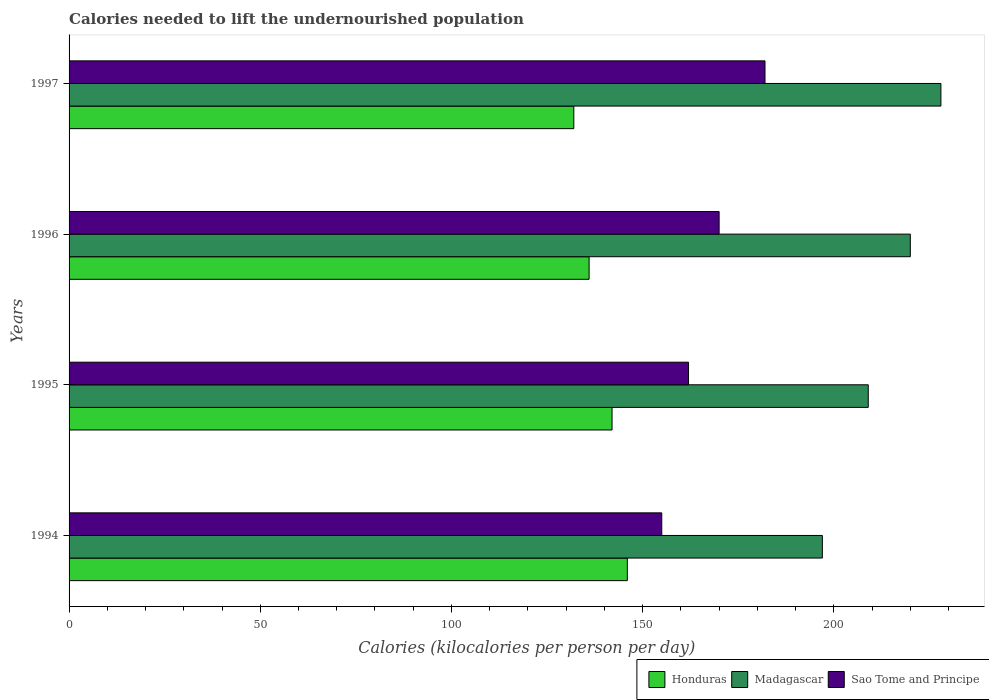How many different coloured bars are there?
Keep it short and to the point. 3. How many groups of bars are there?
Provide a short and direct response. 4. Are the number of bars on each tick of the Y-axis equal?
Your response must be concise. Yes. How many bars are there on the 4th tick from the top?
Keep it short and to the point. 3. What is the label of the 4th group of bars from the top?
Provide a succinct answer. 1994. In how many cases, is the number of bars for a given year not equal to the number of legend labels?
Ensure brevity in your answer.  0. What is the total calories needed to lift the undernourished population in Honduras in 1997?
Ensure brevity in your answer.  132. Across all years, what is the maximum total calories needed to lift the undernourished population in Sao Tome and Principe?
Make the answer very short. 182. Across all years, what is the minimum total calories needed to lift the undernourished population in Madagascar?
Provide a succinct answer. 197. In which year was the total calories needed to lift the undernourished population in Sao Tome and Principe maximum?
Make the answer very short. 1997. In which year was the total calories needed to lift the undernourished population in Sao Tome and Principe minimum?
Your answer should be very brief. 1994. What is the total total calories needed to lift the undernourished population in Madagascar in the graph?
Give a very brief answer. 854. What is the difference between the total calories needed to lift the undernourished population in Honduras in 1994 and that in 1996?
Your answer should be compact. 10. What is the difference between the total calories needed to lift the undernourished population in Honduras in 1996 and the total calories needed to lift the undernourished population in Madagascar in 1997?
Offer a terse response. -92. What is the average total calories needed to lift the undernourished population in Sao Tome and Principe per year?
Give a very brief answer. 167.25. In the year 1996, what is the difference between the total calories needed to lift the undernourished population in Honduras and total calories needed to lift the undernourished population in Sao Tome and Principe?
Your answer should be compact. -34. In how many years, is the total calories needed to lift the undernourished population in Sao Tome and Principe greater than 170 kilocalories?
Your answer should be compact. 1. What is the ratio of the total calories needed to lift the undernourished population in Sao Tome and Principe in 1994 to that in 1995?
Your response must be concise. 0.96. What is the difference between the highest and the lowest total calories needed to lift the undernourished population in Honduras?
Provide a short and direct response. 14. In how many years, is the total calories needed to lift the undernourished population in Madagascar greater than the average total calories needed to lift the undernourished population in Madagascar taken over all years?
Offer a very short reply. 2. What does the 1st bar from the top in 1994 represents?
Offer a very short reply. Sao Tome and Principe. What does the 2nd bar from the bottom in 1997 represents?
Offer a terse response. Madagascar. How many years are there in the graph?
Make the answer very short. 4. What is the difference between two consecutive major ticks on the X-axis?
Provide a short and direct response. 50. Does the graph contain grids?
Ensure brevity in your answer.  No. Where does the legend appear in the graph?
Keep it short and to the point. Bottom right. How many legend labels are there?
Provide a short and direct response. 3. How are the legend labels stacked?
Your answer should be compact. Horizontal. What is the title of the graph?
Keep it short and to the point. Calories needed to lift the undernourished population. What is the label or title of the X-axis?
Make the answer very short. Calories (kilocalories per person per day). What is the label or title of the Y-axis?
Offer a very short reply. Years. What is the Calories (kilocalories per person per day) of Honduras in 1994?
Make the answer very short. 146. What is the Calories (kilocalories per person per day) in Madagascar in 1994?
Provide a short and direct response. 197. What is the Calories (kilocalories per person per day) of Sao Tome and Principe in 1994?
Your answer should be compact. 155. What is the Calories (kilocalories per person per day) of Honduras in 1995?
Your response must be concise. 142. What is the Calories (kilocalories per person per day) in Madagascar in 1995?
Keep it short and to the point. 209. What is the Calories (kilocalories per person per day) in Sao Tome and Principe in 1995?
Give a very brief answer. 162. What is the Calories (kilocalories per person per day) of Honduras in 1996?
Give a very brief answer. 136. What is the Calories (kilocalories per person per day) of Madagascar in 1996?
Provide a short and direct response. 220. What is the Calories (kilocalories per person per day) in Sao Tome and Principe in 1996?
Your response must be concise. 170. What is the Calories (kilocalories per person per day) of Honduras in 1997?
Offer a terse response. 132. What is the Calories (kilocalories per person per day) of Madagascar in 1997?
Give a very brief answer. 228. What is the Calories (kilocalories per person per day) of Sao Tome and Principe in 1997?
Offer a terse response. 182. Across all years, what is the maximum Calories (kilocalories per person per day) of Honduras?
Offer a very short reply. 146. Across all years, what is the maximum Calories (kilocalories per person per day) of Madagascar?
Provide a short and direct response. 228. Across all years, what is the maximum Calories (kilocalories per person per day) of Sao Tome and Principe?
Keep it short and to the point. 182. Across all years, what is the minimum Calories (kilocalories per person per day) of Honduras?
Make the answer very short. 132. Across all years, what is the minimum Calories (kilocalories per person per day) in Madagascar?
Your answer should be compact. 197. Across all years, what is the minimum Calories (kilocalories per person per day) in Sao Tome and Principe?
Provide a short and direct response. 155. What is the total Calories (kilocalories per person per day) of Honduras in the graph?
Provide a succinct answer. 556. What is the total Calories (kilocalories per person per day) in Madagascar in the graph?
Keep it short and to the point. 854. What is the total Calories (kilocalories per person per day) in Sao Tome and Principe in the graph?
Provide a short and direct response. 669. What is the difference between the Calories (kilocalories per person per day) of Honduras in 1994 and that in 1995?
Your answer should be very brief. 4. What is the difference between the Calories (kilocalories per person per day) in Madagascar in 1994 and that in 1995?
Ensure brevity in your answer.  -12. What is the difference between the Calories (kilocalories per person per day) of Sao Tome and Principe in 1994 and that in 1995?
Your answer should be compact. -7. What is the difference between the Calories (kilocalories per person per day) in Madagascar in 1994 and that in 1996?
Make the answer very short. -23. What is the difference between the Calories (kilocalories per person per day) of Sao Tome and Principe in 1994 and that in 1996?
Keep it short and to the point. -15. What is the difference between the Calories (kilocalories per person per day) in Madagascar in 1994 and that in 1997?
Your response must be concise. -31. What is the difference between the Calories (kilocalories per person per day) of Sao Tome and Principe in 1994 and that in 1997?
Provide a succinct answer. -27. What is the difference between the Calories (kilocalories per person per day) in Madagascar in 1995 and that in 1996?
Keep it short and to the point. -11. What is the difference between the Calories (kilocalories per person per day) of Sao Tome and Principe in 1995 and that in 1997?
Your answer should be compact. -20. What is the difference between the Calories (kilocalories per person per day) of Madagascar in 1996 and that in 1997?
Your answer should be compact. -8. What is the difference between the Calories (kilocalories per person per day) in Honduras in 1994 and the Calories (kilocalories per person per day) in Madagascar in 1995?
Provide a succinct answer. -63. What is the difference between the Calories (kilocalories per person per day) of Honduras in 1994 and the Calories (kilocalories per person per day) of Sao Tome and Principe in 1995?
Provide a succinct answer. -16. What is the difference between the Calories (kilocalories per person per day) of Honduras in 1994 and the Calories (kilocalories per person per day) of Madagascar in 1996?
Give a very brief answer. -74. What is the difference between the Calories (kilocalories per person per day) in Honduras in 1994 and the Calories (kilocalories per person per day) in Sao Tome and Principe in 1996?
Provide a succinct answer. -24. What is the difference between the Calories (kilocalories per person per day) in Honduras in 1994 and the Calories (kilocalories per person per day) in Madagascar in 1997?
Your answer should be compact. -82. What is the difference between the Calories (kilocalories per person per day) of Honduras in 1994 and the Calories (kilocalories per person per day) of Sao Tome and Principe in 1997?
Offer a terse response. -36. What is the difference between the Calories (kilocalories per person per day) in Madagascar in 1994 and the Calories (kilocalories per person per day) in Sao Tome and Principe in 1997?
Your answer should be very brief. 15. What is the difference between the Calories (kilocalories per person per day) of Honduras in 1995 and the Calories (kilocalories per person per day) of Madagascar in 1996?
Your answer should be compact. -78. What is the difference between the Calories (kilocalories per person per day) of Honduras in 1995 and the Calories (kilocalories per person per day) of Sao Tome and Principe in 1996?
Your answer should be very brief. -28. What is the difference between the Calories (kilocalories per person per day) of Madagascar in 1995 and the Calories (kilocalories per person per day) of Sao Tome and Principe in 1996?
Your answer should be very brief. 39. What is the difference between the Calories (kilocalories per person per day) in Honduras in 1995 and the Calories (kilocalories per person per day) in Madagascar in 1997?
Your answer should be compact. -86. What is the difference between the Calories (kilocalories per person per day) in Honduras in 1995 and the Calories (kilocalories per person per day) in Sao Tome and Principe in 1997?
Offer a terse response. -40. What is the difference between the Calories (kilocalories per person per day) in Honduras in 1996 and the Calories (kilocalories per person per day) in Madagascar in 1997?
Keep it short and to the point. -92. What is the difference between the Calories (kilocalories per person per day) of Honduras in 1996 and the Calories (kilocalories per person per day) of Sao Tome and Principe in 1997?
Keep it short and to the point. -46. What is the average Calories (kilocalories per person per day) of Honduras per year?
Provide a succinct answer. 139. What is the average Calories (kilocalories per person per day) in Madagascar per year?
Your response must be concise. 213.5. What is the average Calories (kilocalories per person per day) in Sao Tome and Principe per year?
Your answer should be compact. 167.25. In the year 1994, what is the difference between the Calories (kilocalories per person per day) of Honduras and Calories (kilocalories per person per day) of Madagascar?
Offer a very short reply. -51. In the year 1994, what is the difference between the Calories (kilocalories per person per day) of Madagascar and Calories (kilocalories per person per day) of Sao Tome and Principe?
Ensure brevity in your answer.  42. In the year 1995, what is the difference between the Calories (kilocalories per person per day) in Honduras and Calories (kilocalories per person per day) in Madagascar?
Your answer should be very brief. -67. In the year 1995, what is the difference between the Calories (kilocalories per person per day) of Madagascar and Calories (kilocalories per person per day) of Sao Tome and Principe?
Your response must be concise. 47. In the year 1996, what is the difference between the Calories (kilocalories per person per day) of Honduras and Calories (kilocalories per person per day) of Madagascar?
Provide a short and direct response. -84. In the year 1996, what is the difference between the Calories (kilocalories per person per day) in Honduras and Calories (kilocalories per person per day) in Sao Tome and Principe?
Your answer should be compact. -34. In the year 1997, what is the difference between the Calories (kilocalories per person per day) of Honduras and Calories (kilocalories per person per day) of Madagascar?
Your response must be concise. -96. In the year 1997, what is the difference between the Calories (kilocalories per person per day) of Honduras and Calories (kilocalories per person per day) of Sao Tome and Principe?
Make the answer very short. -50. In the year 1997, what is the difference between the Calories (kilocalories per person per day) in Madagascar and Calories (kilocalories per person per day) in Sao Tome and Principe?
Make the answer very short. 46. What is the ratio of the Calories (kilocalories per person per day) of Honduras in 1994 to that in 1995?
Make the answer very short. 1.03. What is the ratio of the Calories (kilocalories per person per day) in Madagascar in 1994 to that in 1995?
Give a very brief answer. 0.94. What is the ratio of the Calories (kilocalories per person per day) in Sao Tome and Principe in 1994 to that in 1995?
Your answer should be compact. 0.96. What is the ratio of the Calories (kilocalories per person per day) of Honduras in 1994 to that in 1996?
Your answer should be very brief. 1.07. What is the ratio of the Calories (kilocalories per person per day) of Madagascar in 1994 to that in 1996?
Provide a succinct answer. 0.9. What is the ratio of the Calories (kilocalories per person per day) in Sao Tome and Principe in 1994 to that in 1996?
Ensure brevity in your answer.  0.91. What is the ratio of the Calories (kilocalories per person per day) in Honduras in 1994 to that in 1997?
Your answer should be very brief. 1.11. What is the ratio of the Calories (kilocalories per person per day) in Madagascar in 1994 to that in 1997?
Offer a very short reply. 0.86. What is the ratio of the Calories (kilocalories per person per day) of Sao Tome and Principe in 1994 to that in 1997?
Keep it short and to the point. 0.85. What is the ratio of the Calories (kilocalories per person per day) of Honduras in 1995 to that in 1996?
Your answer should be very brief. 1.04. What is the ratio of the Calories (kilocalories per person per day) of Sao Tome and Principe in 1995 to that in 1996?
Your response must be concise. 0.95. What is the ratio of the Calories (kilocalories per person per day) of Honduras in 1995 to that in 1997?
Your answer should be very brief. 1.08. What is the ratio of the Calories (kilocalories per person per day) of Sao Tome and Principe in 1995 to that in 1997?
Provide a succinct answer. 0.89. What is the ratio of the Calories (kilocalories per person per day) in Honduras in 1996 to that in 1997?
Offer a terse response. 1.03. What is the ratio of the Calories (kilocalories per person per day) in Madagascar in 1996 to that in 1997?
Offer a very short reply. 0.96. What is the ratio of the Calories (kilocalories per person per day) of Sao Tome and Principe in 1996 to that in 1997?
Your answer should be compact. 0.93. What is the difference between the highest and the second highest Calories (kilocalories per person per day) in Madagascar?
Give a very brief answer. 8. What is the difference between the highest and the lowest Calories (kilocalories per person per day) of Sao Tome and Principe?
Keep it short and to the point. 27. 